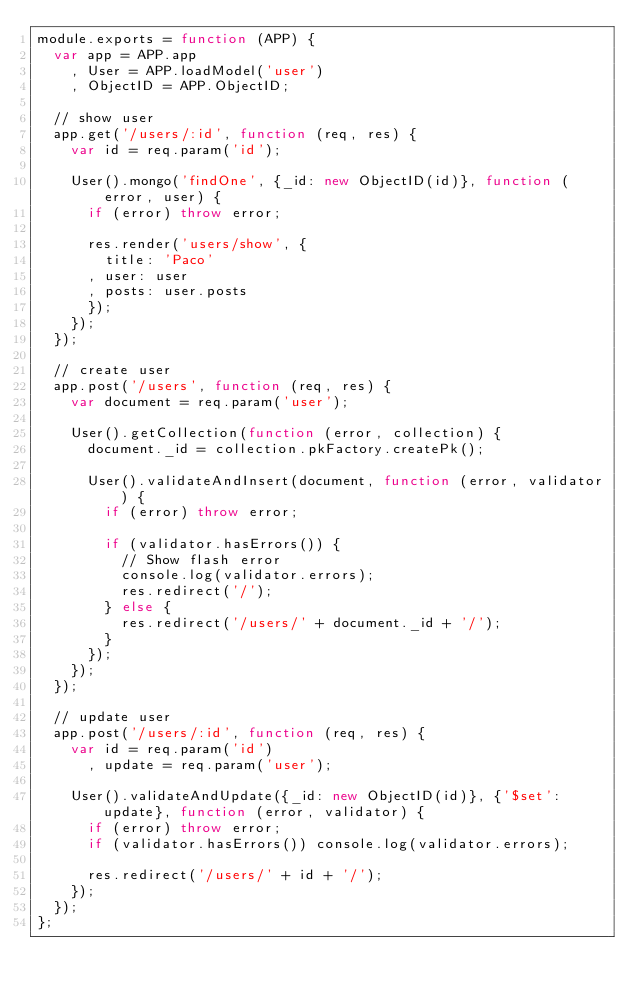<code> <loc_0><loc_0><loc_500><loc_500><_JavaScript_>module.exports = function (APP) {
  var app = APP.app
    , User = APP.loadModel('user')
    , ObjectID = APP.ObjectID;

  // show user
  app.get('/users/:id', function (req, res) {
    var id = req.param('id');

    User().mongo('findOne', {_id: new ObjectID(id)}, function (error, user) {
      if (error) throw error;

      res.render('users/show', {
        title: 'Paco'
      , user: user
      , posts: user.posts
      });
    });
  });

  // create user
  app.post('/users', function (req, res) {
    var document = req.param('user');

    User().getCollection(function (error, collection) {
      document._id = collection.pkFactory.createPk();

      User().validateAndInsert(document, function (error, validator) {
        if (error) throw error;

        if (validator.hasErrors()) {
          // Show flash error
          console.log(validator.errors);
          res.redirect('/');
        } else {
          res.redirect('/users/' + document._id + '/');
        }
      });
    });
  });

  // update user
  app.post('/users/:id', function (req, res) {
    var id = req.param('id')
      , update = req.param('user');

    User().validateAndUpdate({_id: new ObjectID(id)}, {'$set': update}, function (error, validator) {
      if (error) throw error;
      if (validator.hasErrors()) console.log(validator.errors);

      res.redirect('/users/' + id + '/');
    });
  });
};
</code> 